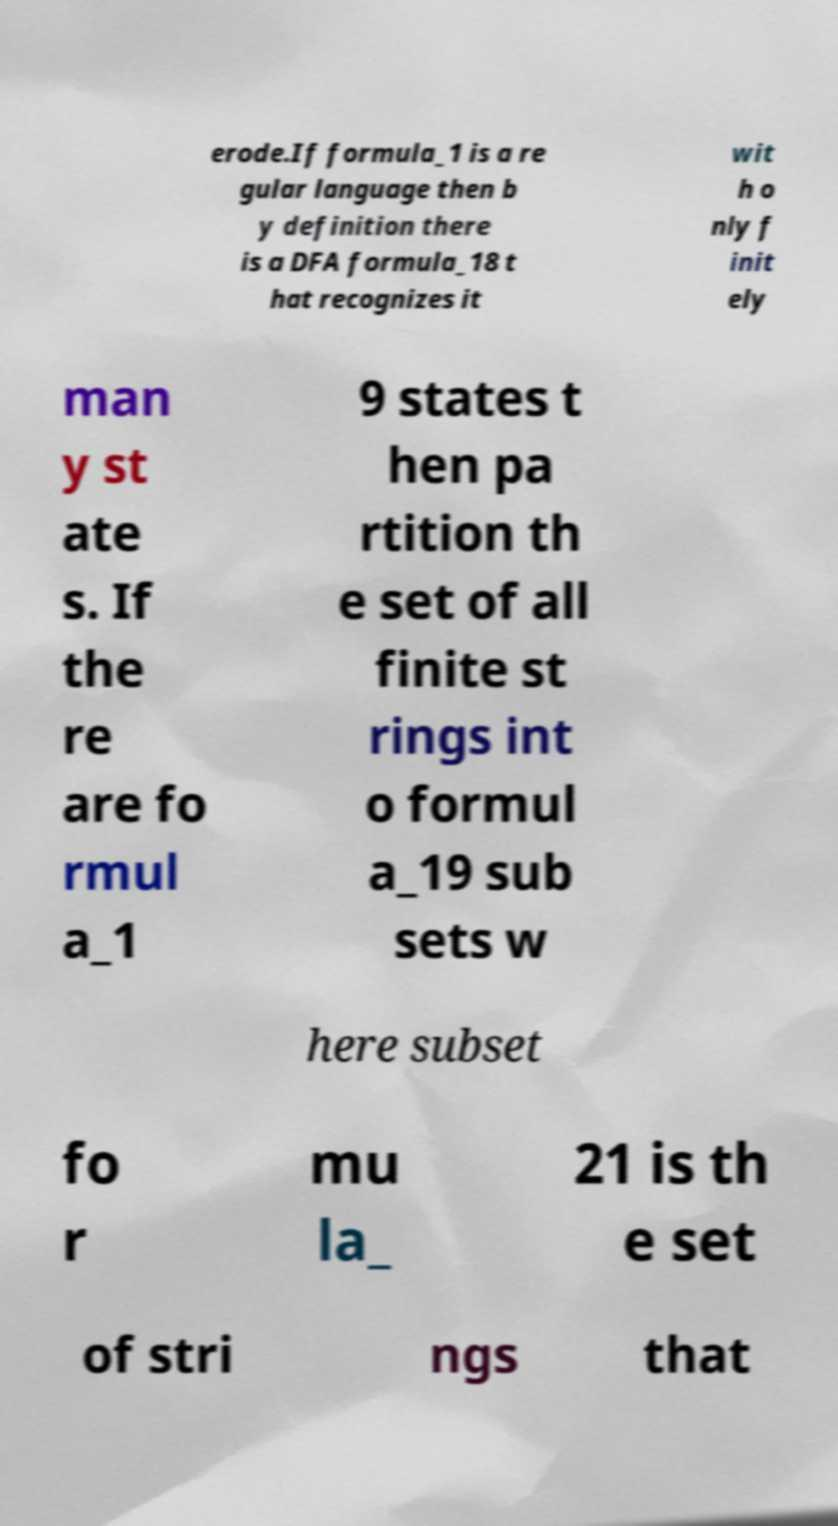Can you accurately transcribe the text from the provided image for me? erode.If formula_1 is a re gular language then b y definition there is a DFA formula_18 t hat recognizes it wit h o nly f init ely man y st ate s. If the re are fo rmul a_1 9 states t hen pa rtition th e set of all finite st rings int o formul a_19 sub sets w here subset fo r mu la_ 21 is th e set of stri ngs that 